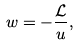<formula> <loc_0><loc_0><loc_500><loc_500>w = - \frac { \mathcal { L } } { u } ,</formula> 